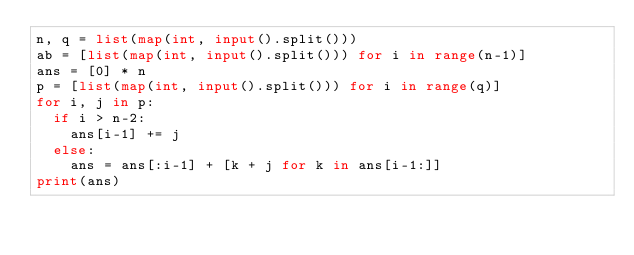<code> <loc_0><loc_0><loc_500><loc_500><_Python_>n, q = list(map(int, input().split()))
ab = [list(map(int, input().split())) for i in range(n-1)]
ans = [0] * n
p = [list(map(int, input().split())) for i in range(q)]
for i, j in p:
  if i > n-2:
    ans[i-1] += j
  else:
    ans = ans[:i-1] + [k + j for k in ans[i-1:]]
print(ans)</code> 